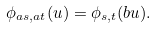Convert formula to latex. <formula><loc_0><loc_0><loc_500><loc_500>\phi _ { a s , a t } ( u ) = \phi _ { s , t } ( b u ) .</formula> 